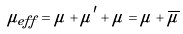Convert formula to latex. <formula><loc_0><loc_0><loc_500><loc_500>\mu _ { e f f } = \mu + \mu ^ { \prime } + \tilde { \mu } = \mu + \overline { \mu }</formula> 